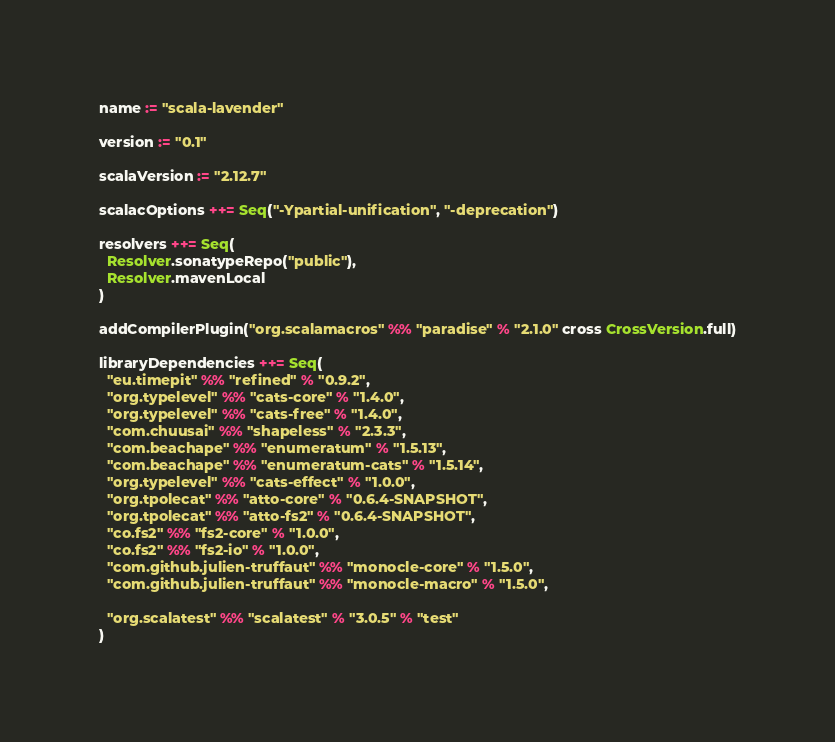<code> <loc_0><loc_0><loc_500><loc_500><_Scala_>name := "scala-lavender"

version := "0.1"

scalaVersion := "2.12.7"

scalacOptions ++= Seq("-Ypartial-unification", "-deprecation")

resolvers ++= Seq(
  Resolver.sonatypeRepo("public"),
  Resolver.mavenLocal
)

addCompilerPlugin("org.scalamacros" %% "paradise" % "2.1.0" cross CrossVersion.full)

libraryDependencies ++= Seq(
  "eu.timepit" %% "refined" % "0.9.2",
  "org.typelevel" %% "cats-core" % "1.4.0",
  "org.typelevel" %% "cats-free" % "1.4.0",
  "com.chuusai" %% "shapeless" % "2.3.3",
  "com.beachape" %% "enumeratum" % "1.5.13",
  "com.beachape" %% "enumeratum-cats" % "1.5.14",
  "org.typelevel" %% "cats-effect" % "1.0.0",
  "org.tpolecat" %% "atto-core" % "0.6.4-SNAPSHOT",
  "org.tpolecat" %% "atto-fs2" % "0.6.4-SNAPSHOT",
  "co.fs2" %% "fs2-core" % "1.0.0",
  "co.fs2" %% "fs2-io" % "1.0.0",
  "com.github.julien-truffaut" %% "monocle-core" % "1.5.0",
  "com.github.julien-truffaut" %% "monocle-macro" % "1.5.0",

  "org.scalatest" %% "scalatest" % "3.0.5" % "test"
)
</code> 